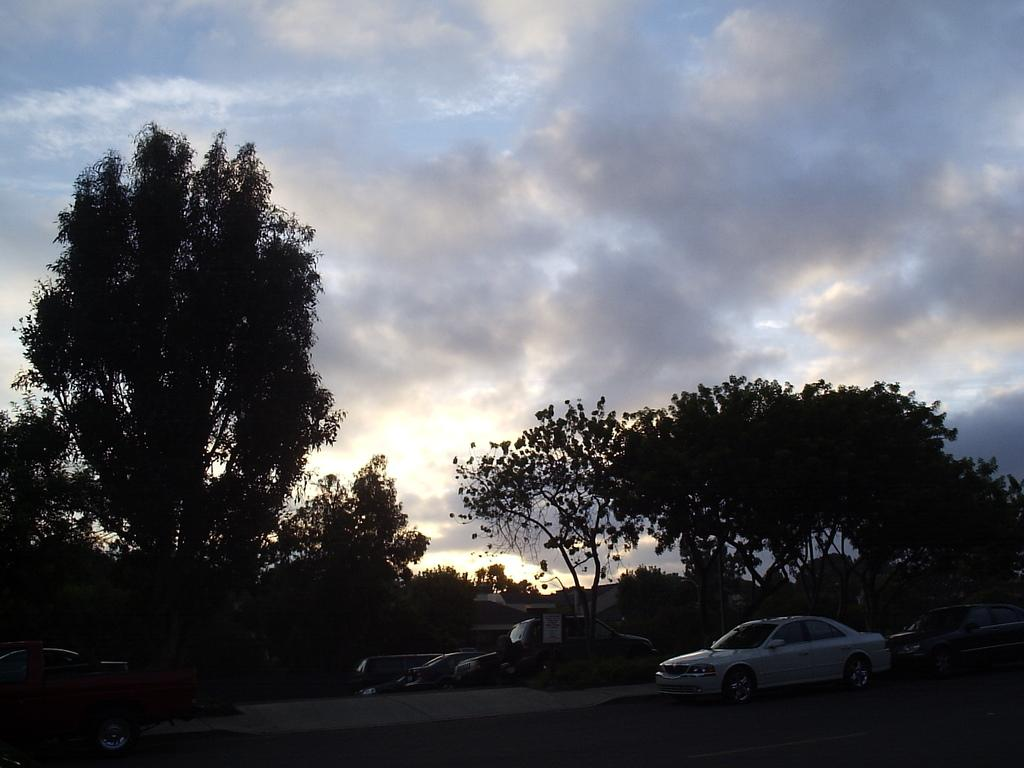What can be seen on the road in the image? There are vehicles on the road in the image. What is visible in the background of the image? There are trees and clouds in the sky visible in the background of the image. What type of ornament is hanging from the trees in the image? There are no ornaments hanging from the trees in the image; only trees and clouds are visible in the background. 